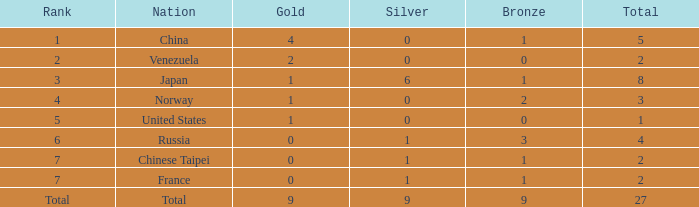What is the mean bronze for position 3 and sum exceeding 8? None. 